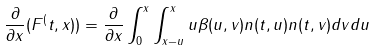Convert formula to latex. <formula><loc_0><loc_0><loc_500><loc_500>\frac { \partial } { \partial x } ( F ^ { ( } t , x ) ) = \frac { \partial } { \partial x } \int _ { 0 } ^ { x } \int _ { x - u } ^ { x } u \beta ( u , v ) n ( t , u ) n ( t , v ) d v d u</formula> 